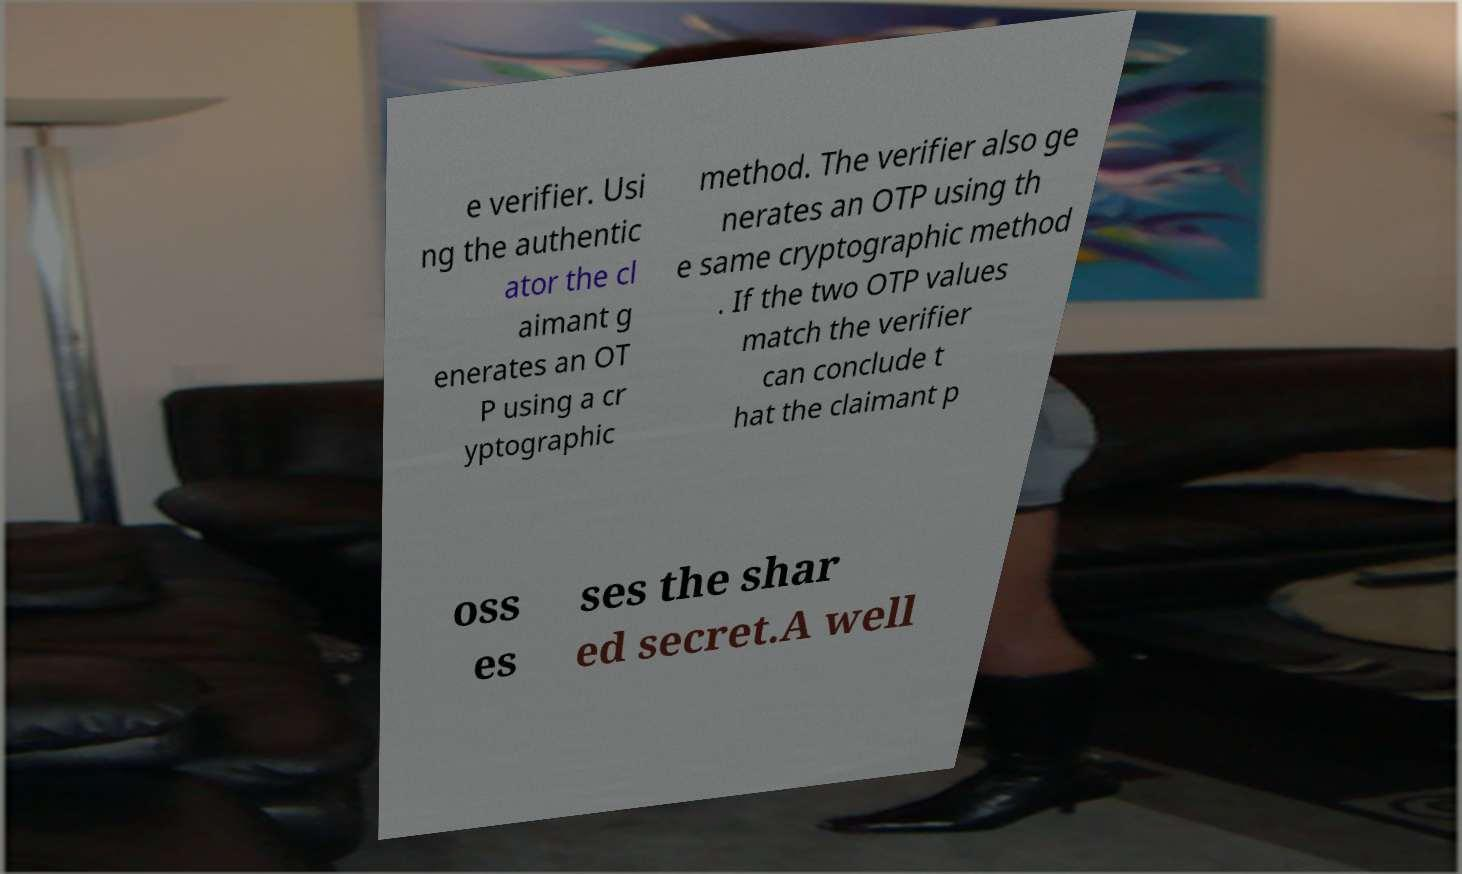Please identify and transcribe the text found in this image. e verifier. Usi ng the authentic ator the cl aimant g enerates an OT P using a cr yptographic method. The verifier also ge nerates an OTP using th e same cryptographic method . If the two OTP values match the verifier can conclude t hat the claimant p oss es ses the shar ed secret.A well 